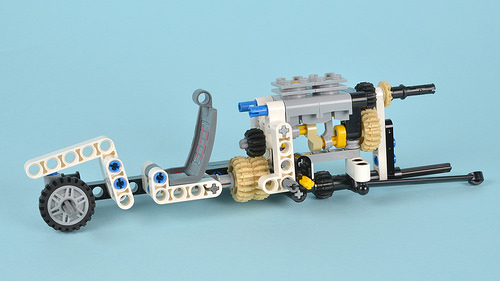<image>
Is the wheel next to the seat? No. The wheel is not positioned next to the seat. They are located in different areas of the scene. 